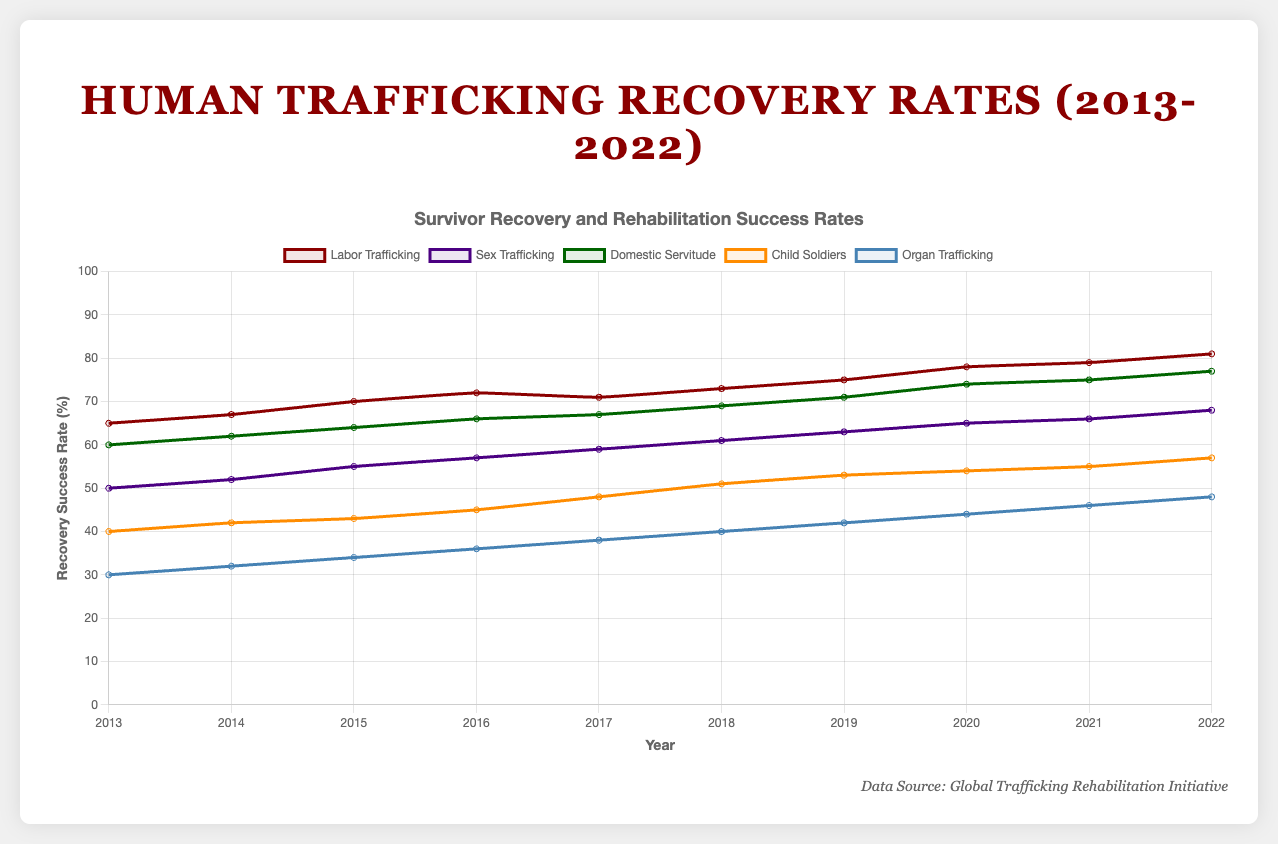What is the recovery success rate for labor trafficking in 2015? The figure shows various curves representing different types of trafficking recovery success rates over the years. Look at the curve for labor trafficking and find the value for the year 2015. The value is 70.
Answer: 70 Which type of trafficking has the lowest recovery success rate in 2022? Analyze the end points of all the curves in the figure for the year 2022. The lowest end point among the curves belongs to organ trafficking.
Answer: Organ trafficking By how much did the recovery success rate for child soldiers increase from 2013 to 2022? Find the recovery success rate for child soldiers in 2013 and 2022 by looking at the values on the curve for those years. The difference is 57 (in 2022) - 40 (in 2013) = 17.
Answer: 17 Which two types of trafficking had the same recovery success rate in 2015? Locate the values for each type of trafficking for the year 2015. Domestic servitude and sex trafficking both have a recovery success rate of 64 in 2015.
Answer: Domestic servitude and sex trafficking What is the average recovery success rate for sex trafficking over the 10 years? Add all the yearly recovery success rates for sex trafficking and then divide by the number of years (10). The calculation is (50 + 52 + 55 + 57 + 59 + 61 + 63 + 65 + 66 + 68) / 10 = 59.6.
Answer: 59.6 Which type of trafficking showed the highest overall increase in recovery success rate from 2013 to 2022? Compare the increase in recovery success rates for each type of trafficking from 2013 to 2022. Labor trafficking increased by 81 - 65 = 16, sex trafficking by 68 - 50 = 18, domestic servitude by 77 - 60 = 17, child soldiers by 57 - 40 = 17, and organ trafficking by 48 - 30 = 18. The greatest increase is for sex trafficking and organ trafficking.
Answer: Sex trafficking and organ trafficking What is the median recovery success rate for labor trafficking from 2013 to 2022? List the values for labor trafficking in ascending order: 65, 67, 70, 71, 72, 73, 75, 78, 79, 81. Since there are 10 values, the median is the average of the 5th and 6th values: (72 + 73) / 2 = 72.5.
Answer: 72.5 How do the recovery success rates for domestic servitude and child soldiers compare in 2020? Look at the values for both domestic servitude and child soldiers for the year 2020. Domestic servitude has a recovery success rate of 74, while child soldiers have a rate of 54. The recovery success rate for domestic servitude is higher.
Answer: Higher for domestic servitude 